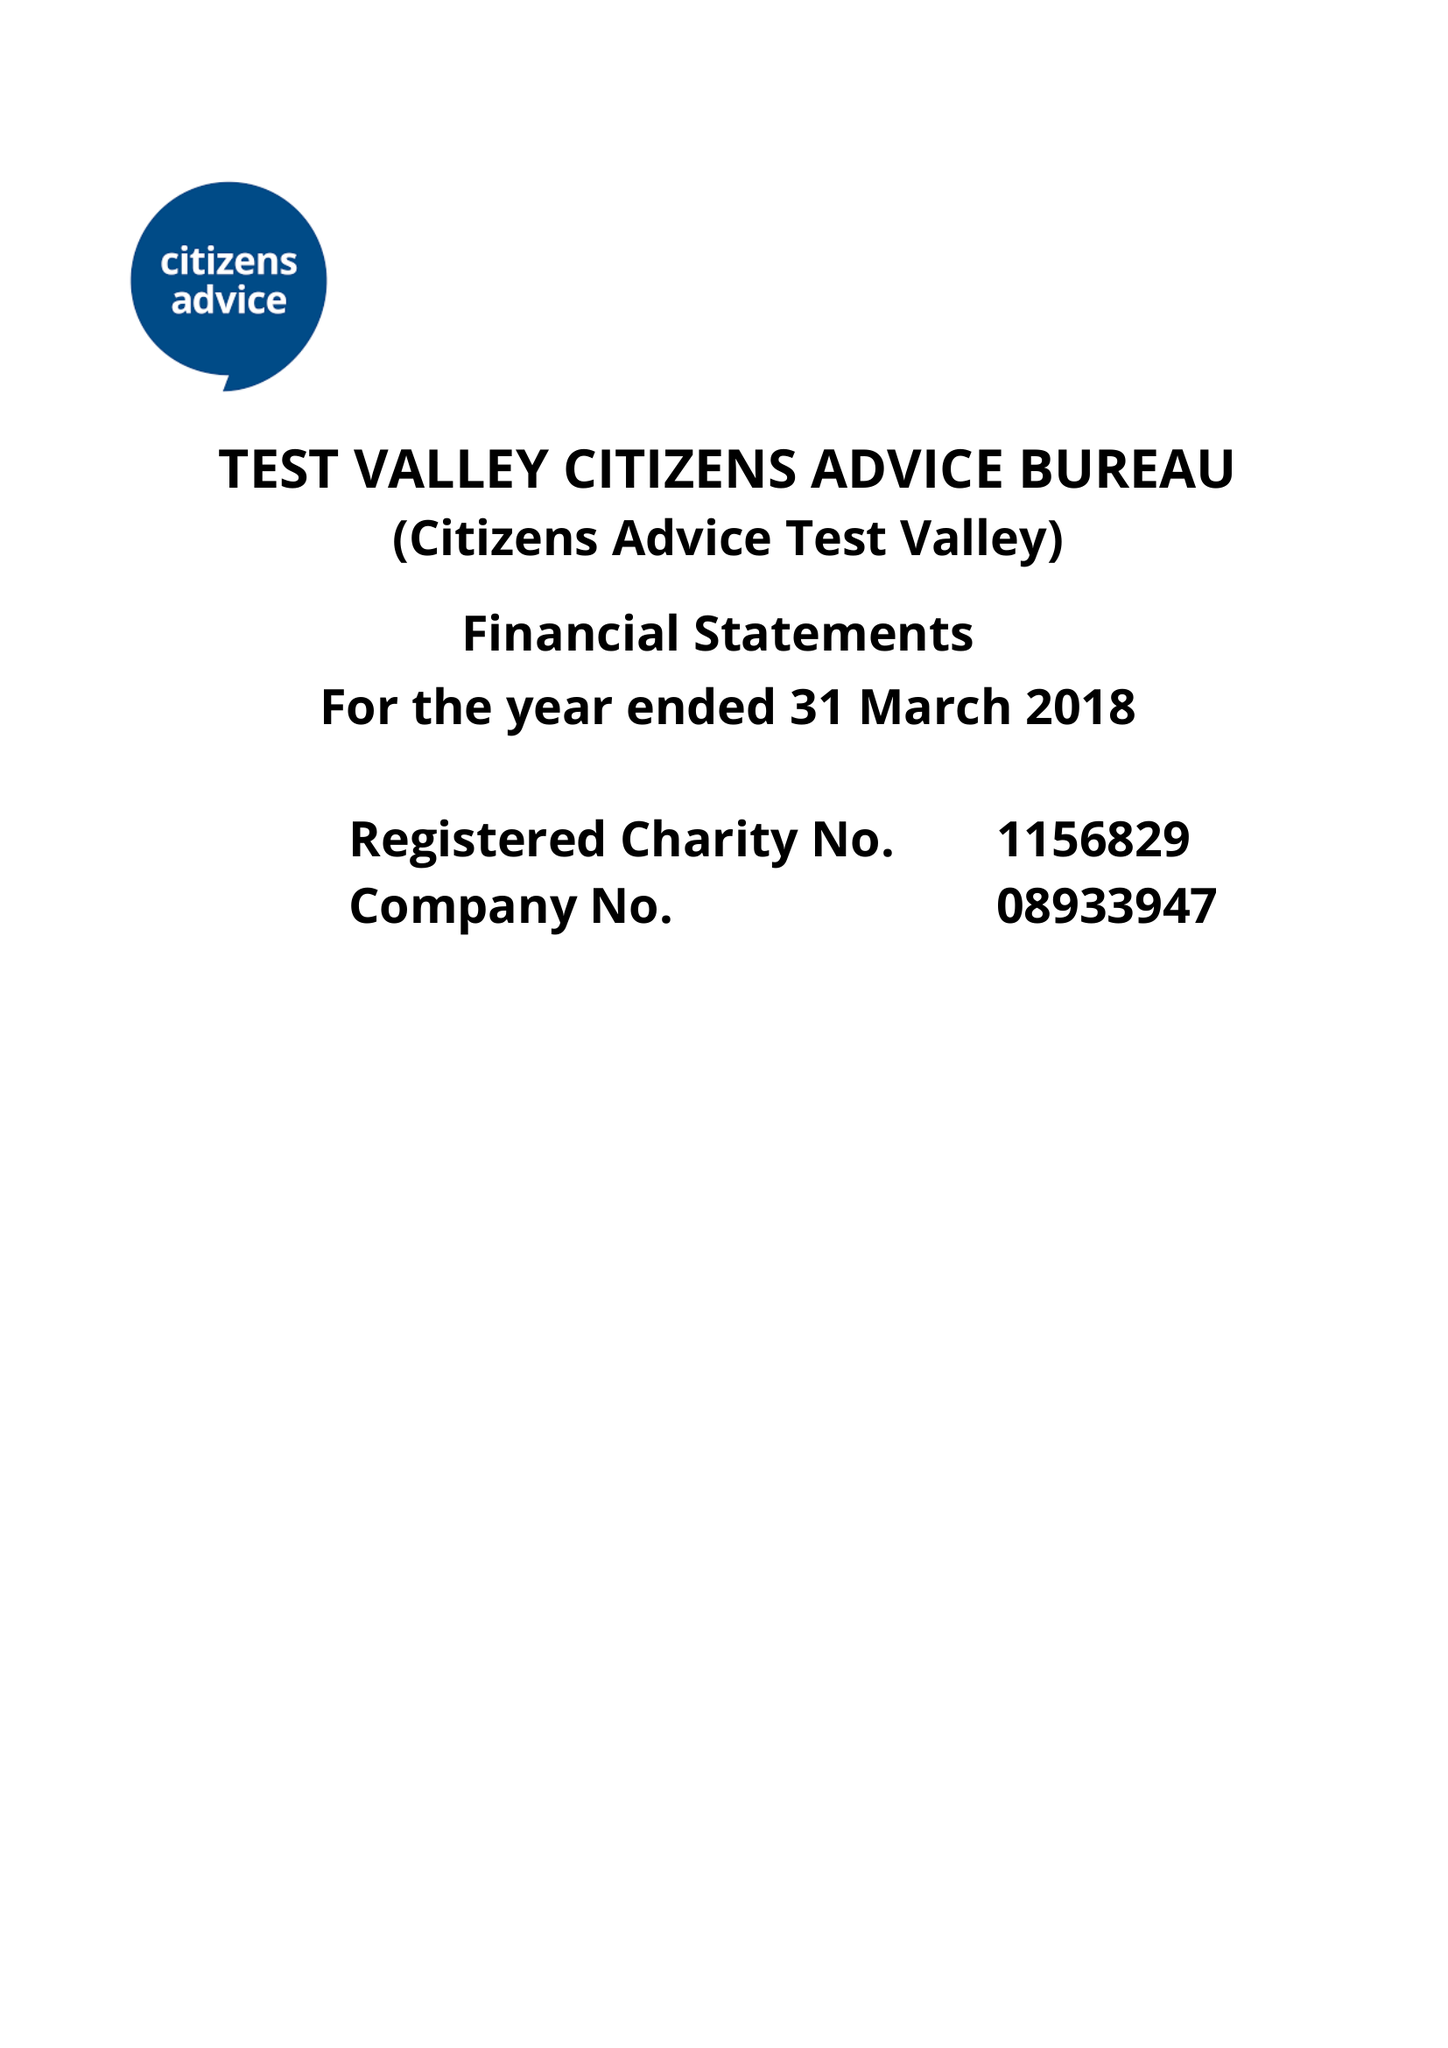What is the value for the charity_number?
Answer the question using a single word or phrase. 1156829 